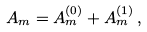<formula> <loc_0><loc_0><loc_500><loc_500>A _ { m } = A _ { m } ^ { ( 0 ) } + A _ { m } ^ { ( 1 ) } \, ,</formula> 